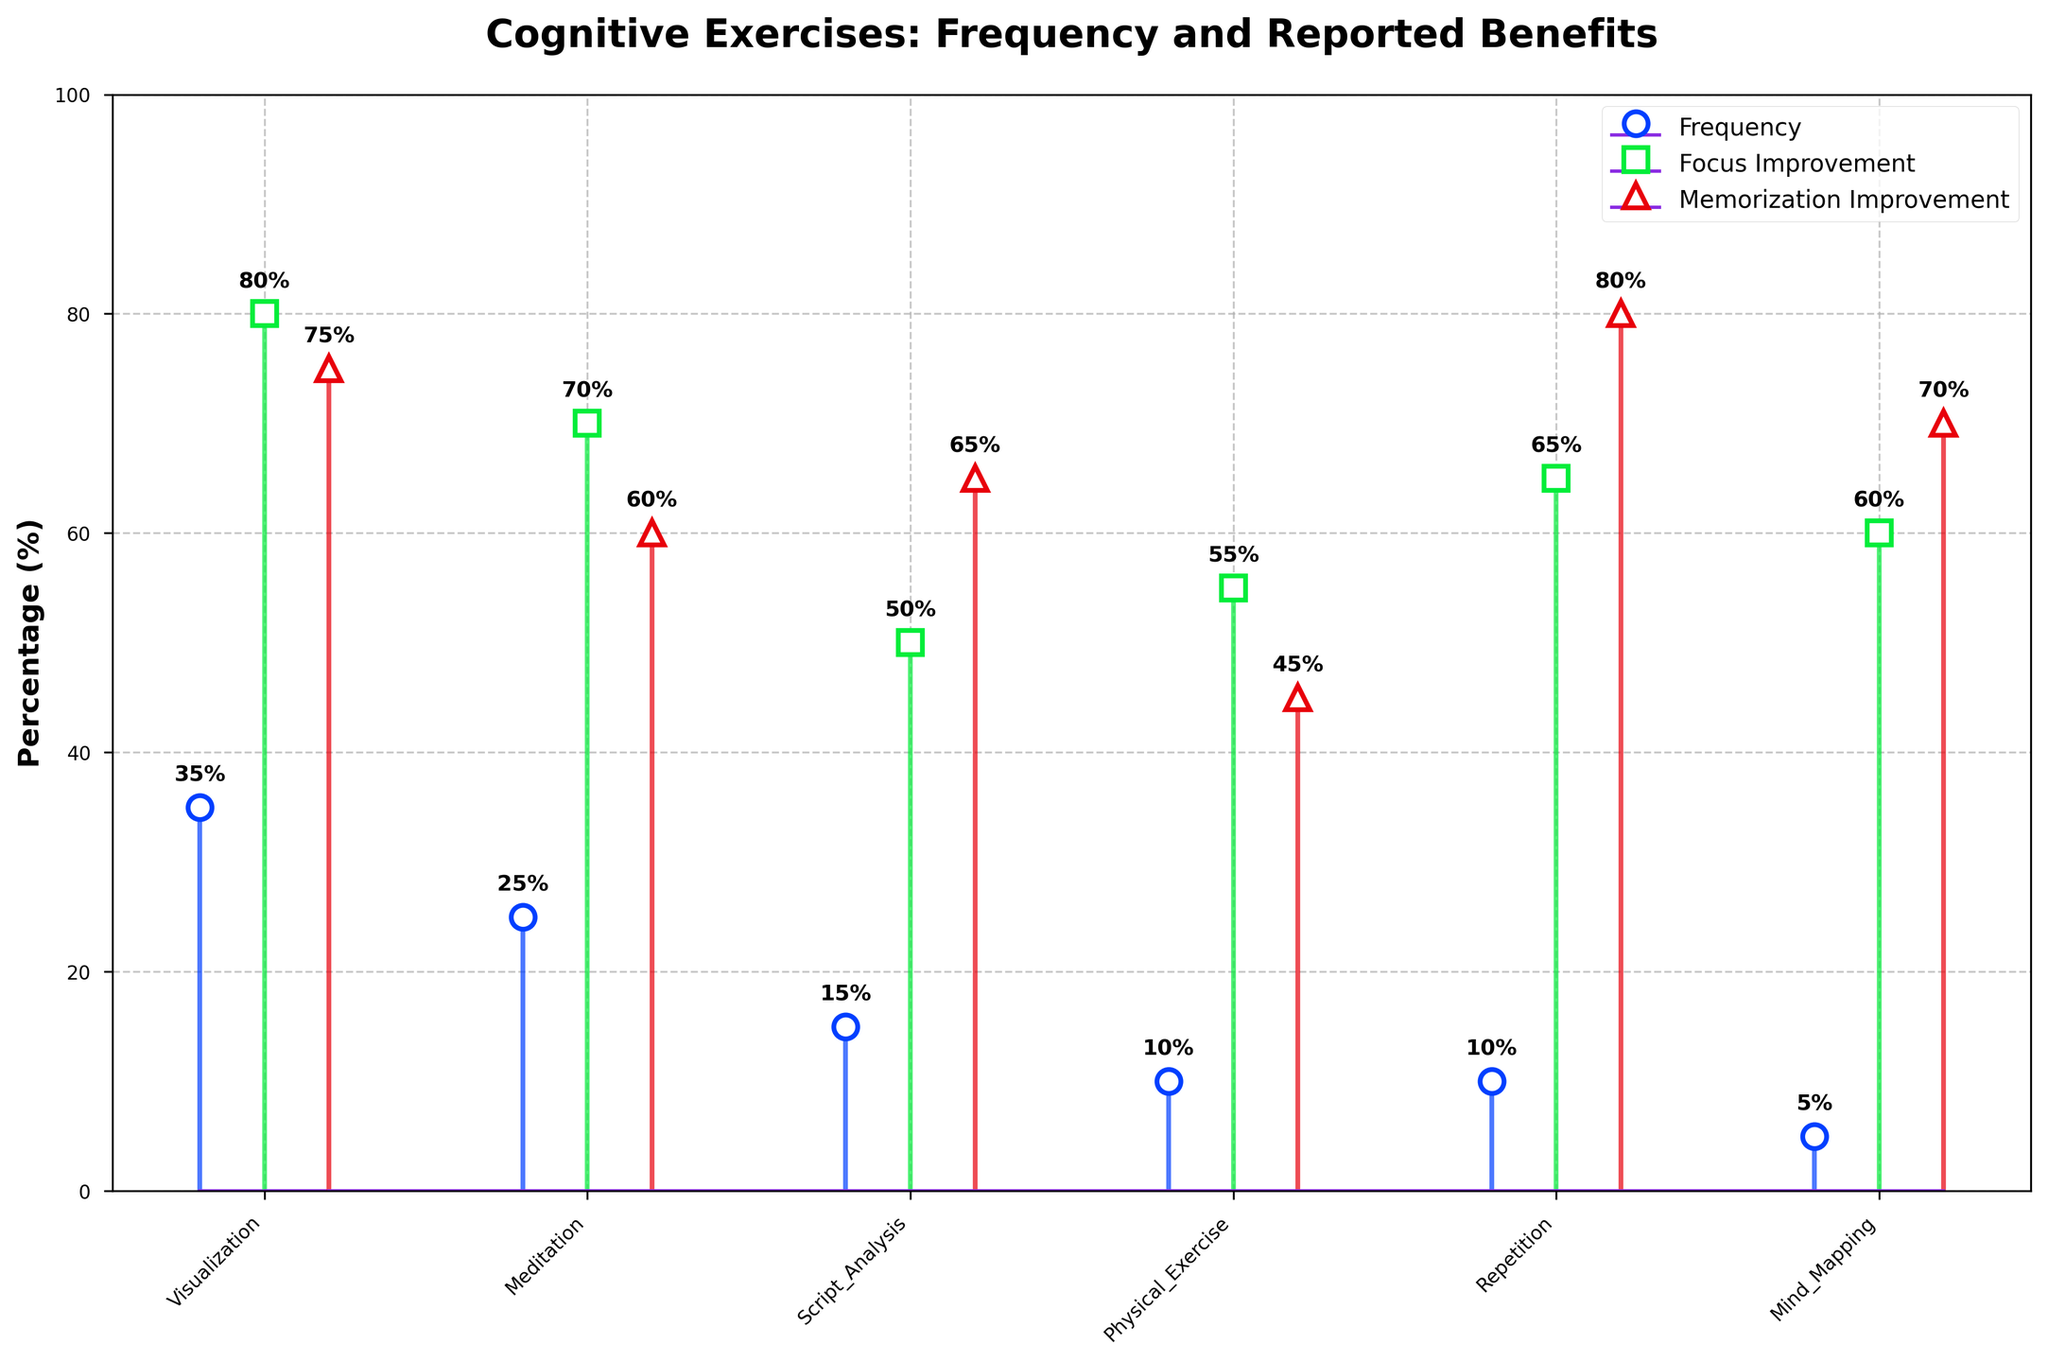What's the title of the figure? The title is located at the top of the figure, typically in a larger and bold font. It summarizes the main topic of the plot.
Answer: Cognitive Exercises: Frequency and Reported Benefits What is the reported memorization improvement percentage for Repetition? Look for the stem marked with a triangle (^) for Repetition and check the corresponding percentage value labeled near the top of the line.
Answer: 80% Which cognitive exercise is reported to have the highest focus improvement percentage? Identify the stem with the highest value among those marked with a square (□). Compare all focus improvement percentages to find the highest one.
Answer: Visualization Comparing Visualization and Meditation, which cognitive exercise has a higher frequency percentage? Locate the stems for Visualization and Meditation marked with circles (o) and compare their height values to determine the higher one.
Answer: Visualization What is the difference in memorization improvement percentage between Visualization and Script Analysis? Find the memorization improvement percentages for both Visualization and Script Analysis, then subtract Script Analysis's percentage from Visualization's percentage. The Visualization's memorization improvement percentage is 75%, and Script Analysis's is 65%.
Answer: 75% - 65% = 10% How many exercises have a memorization improvement percentage of 70% or higher? Identify all stems with triangles (^) having percentages equal to or greater than 70% and count them.
Answer: 4 Which cognitive exercise has equal percentages for both memorization and focus improvements? Compare the percentages of memorization and focus improvements for all exercises to find any that match.
Answer: None Among all exercises, which one has the lowest frequency percentage? Locate the exercise with the shortest stem height in the category marked with circles (o).
Answer: Mind Mapping What is the average focus improvement percentage for Meditation and Physical Exercise? Add the focus improvement percentages for Meditation (70%) and Physical Exercise (55%), then divide by 2 to find the average.
Answer: (70% + 55%) / 2 = 62.5% Which exercise, among Repetition and Mind Mapping, shows a higher frequency percentage? Compare the frequency percentages for Repetition and Mind Mapping.
Answer: Repetition 